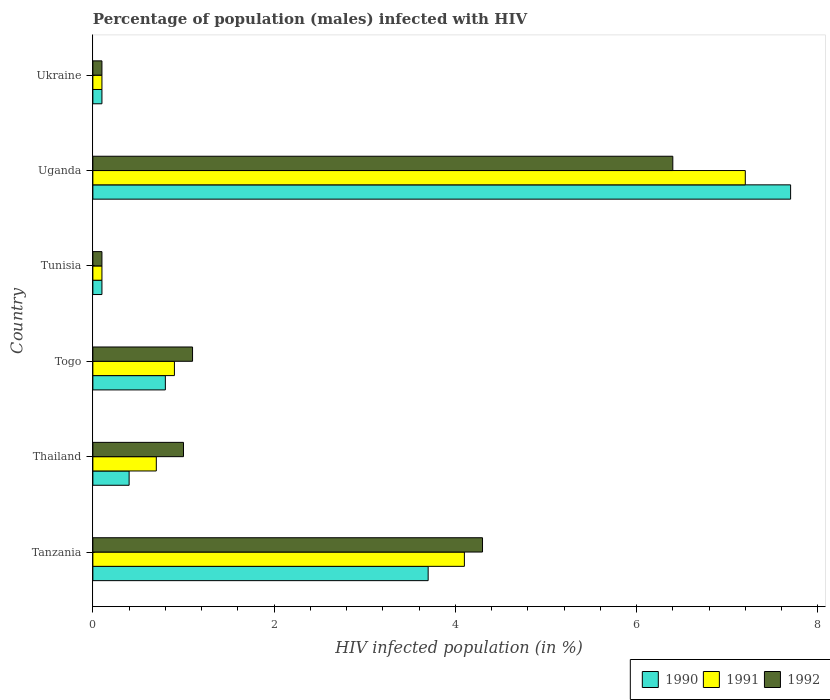Are the number of bars per tick equal to the number of legend labels?
Keep it short and to the point. Yes. Are the number of bars on each tick of the Y-axis equal?
Offer a terse response. Yes. How many bars are there on the 2nd tick from the bottom?
Your answer should be very brief. 3. What is the label of the 6th group of bars from the top?
Ensure brevity in your answer.  Tanzania. What is the percentage of HIV infected male population in 1992 in Tanzania?
Provide a short and direct response. 4.3. Across all countries, what is the maximum percentage of HIV infected male population in 1992?
Keep it short and to the point. 6.4. In which country was the percentage of HIV infected male population in 1991 maximum?
Your answer should be compact. Uganda. In which country was the percentage of HIV infected male population in 1990 minimum?
Offer a very short reply. Tunisia. What is the difference between the percentage of HIV infected male population in 1990 in Uganda and the percentage of HIV infected male population in 1992 in Tanzania?
Ensure brevity in your answer.  3.4. What is the average percentage of HIV infected male population in 1992 per country?
Keep it short and to the point. 2.17. What is the difference between the percentage of HIV infected male population in 1990 and percentage of HIV infected male population in 1991 in Togo?
Provide a succinct answer. -0.1. What is the ratio of the percentage of HIV infected male population in 1990 in Togo to that in Uganda?
Offer a very short reply. 0.1. Is the percentage of HIV infected male population in 1990 in Tanzania less than that in Thailand?
Your response must be concise. No. What is the difference between the highest and the second highest percentage of HIV infected male population in 1991?
Your answer should be very brief. 3.1. What is the difference between the highest and the lowest percentage of HIV infected male population in 1992?
Your answer should be compact. 6.3. What does the 2nd bar from the bottom in Thailand represents?
Offer a terse response. 1991. Is it the case that in every country, the sum of the percentage of HIV infected male population in 1991 and percentage of HIV infected male population in 1990 is greater than the percentage of HIV infected male population in 1992?
Offer a very short reply. Yes. What is the difference between two consecutive major ticks on the X-axis?
Give a very brief answer. 2. Are the values on the major ticks of X-axis written in scientific E-notation?
Offer a very short reply. No. Does the graph contain any zero values?
Offer a very short reply. No. Where does the legend appear in the graph?
Ensure brevity in your answer.  Bottom right. What is the title of the graph?
Give a very brief answer. Percentage of population (males) infected with HIV. What is the label or title of the X-axis?
Offer a terse response. HIV infected population (in %). What is the label or title of the Y-axis?
Ensure brevity in your answer.  Country. What is the HIV infected population (in %) in 1990 in Tanzania?
Offer a very short reply. 3.7. What is the HIV infected population (in %) of 1991 in Tanzania?
Keep it short and to the point. 4.1. What is the HIV infected population (in %) in 1990 in Thailand?
Make the answer very short. 0.4. What is the HIV infected population (in %) of 1992 in Togo?
Make the answer very short. 1.1. What is the HIV infected population (in %) of 1991 in Uganda?
Ensure brevity in your answer.  7.2. What is the HIV infected population (in %) in 1992 in Uganda?
Your response must be concise. 6.4. What is the HIV infected population (in %) of 1990 in Ukraine?
Your answer should be compact. 0.1. Across all countries, what is the maximum HIV infected population (in %) of 1990?
Make the answer very short. 7.7. Across all countries, what is the maximum HIV infected population (in %) in 1992?
Give a very brief answer. 6.4. Across all countries, what is the minimum HIV infected population (in %) of 1990?
Provide a short and direct response. 0.1. Across all countries, what is the minimum HIV infected population (in %) of 1991?
Ensure brevity in your answer.  0.1. What is the total HIV infected population (in %) of 1991 in the graph?
Keep it short and to the point. 13.1. What is the difference between the HIV infected population (in %) in 1992 in Tanzania and that in Thailand?
Make the answer very short. 3.3. What is the difference between the HIV infected population (in %) of 1990 in Tanzania and that in Togo?
Your response must be concise. 2.9. What is the difference between the HIV infected population (in %) of 1990 in Tanzania and that in Tunisia?
Provide a short and direct response. 3.6. What is the difference between the HIV infected population (in %) of 1992 in Tanzania and that in Uganda?
Provide a short and direct response. -2.1. What is the difference between the HIV infected population (in %) of 1990 in Tanzania and that in Ukraine?
Provide a short and direct response. 3.6. What is the difference between the HIV infected population (in %) in 1992 in Tanzania and that in Ukraine?
Give a very brief answer. 4.2. What is the difference between the HIV infected population (in %) in 1992 in Thailand and that in Togo?
Offer a terse response. -0.1. What is the difference between the HIV infected population (in %) in 1990 in Thailand and that in Tunisia?
Your response must be concise. 0.3. What is the difference between the HIV infected population (in %) of 1992 in Thailand and that in Tunisia?
Your response must be concise. 0.9. What is the difference between the HIV infected population (in %) of 1990 in Thailand and that in Uganda?
Keep it short and to the point. -7.3. What is the difference between the HIV infected population (in %) in 1991 in Thailand and that in Uganda?
Your response must be concise. -6.5. What is the difference between the HIV infected population (in %) in 1991 in Thailand and that in Ukraine?
Your answer should be very brief. 0.6. What is the difference between the HIV infected population (in %) in 1990 in Togo and that in Tunisia?
Provide a short and direct response. 0.7. What is the difference between the HIV infected population (in %) of 1991 in Togo and that in Tunisia?
Your answer should be very brief. 0.8. What is the difference between the HIV infected population (in %) of 1990 in Togo and that in Uganda?
Offer a terse response. -6.9. What is the difference between the HIV infected population (in %) in 1991 in Togo and that in Uganda?
Offer a very short reply. -6.3. What is the difference between the HIV infected population (in %) of 1991 in Togo and that in Ukraine?
Your answer should be very brief. 0.8. What is the difference between the HIV infected population (in %) of 1992 in Togo and that in Ukraine?
Make the answer very short. 1. What is the difference between the HIV infected population (in %) in 1992 in Tunisia and that in Uganda?
Your answer should be compact. -6.3. What is the difference between the HIV infected population (in %) of 1992 in Tunisia and that in Ukraine?
Your response must be concise. 0. What is the difference between the HIV infected population (in %) in 1990 in Uganda and that in Ukraine?
Your answer should be very brief. 7.6. What is the difference between the HIV infected population (in %) in 1990 in Tanzania and the HIV infected population (in %) in 1992 in Thailand?
Make the answer very short. 2.7. What is the difference between the HIV infected population (in %) in 1991 in Tanzania and the HIV infected population (in %) in 1992 in Thailand?
Your answer should be very brief. 3.1. What is the difference between the HIV infected population (in %) of 1990 in Tanzania and the HIV infected population (in %) of 1992 in Togo?
Offer a terse response. 2.6. What is the difference between the HIV infected population (in %) of 1991 in Tanzania and the HIV infected population (in %) of 1992 in Togo?
Your answer should be very brief. 3. What is the difference between the HIV infected population (in %) in 1991 in Tanzania and the HIV infected population (in %) in 1992 in Tunisia?
Your answer should be very brief. 4. What is the difference between the HIV infected population (in %) in 1990 in Tanzania and the HIV infected population (in %) in 1991 in Uganda?
Your answer should be very brief. -3.5. What is the difference between the HIV infected population (in %) of 1991 in Tanzania and the HIV infected population (in %) of 1992 in Uganda?
Offer a very short reply. -2.3. What is the difference between the HIV infected population (in %) of 1990 in Tanzania and the HIV infected population (in %) of 1992 in Ukraine?
Your answer should be compact. 3.6. What is the difference between the HIV infected population (in %) in 1991 in Tanzania and the HIV infected population (in %) in 1992 in Ukraine?
Your response must be concise. 4. What is the difference between the HIV infected population (in %) of 1990 in Thailand and the HIV infected population (in %) of 1991 in Togo?
Your answer should be very brief. -0.5. What is the difference between the HIV infected population (in %) in 1990 in Thailand and the HIV infected population (in %) in 1992 in Togo?
Your answer should be very brief. -0.7. What is the difference between the HIV infected population (in %) in 1990 in Thailand and the HIV infected population (in %) in 1991 in Tunisia?
Offer a very short reply. 0.3. What is the difference between the HIV infected population (in %) of 1990 in Thailand and the HIV infected population (in %) of 1992 in Tunisia?
Your answer should be compact. 0.3. What is the difference between the HIV infected population (in %) of 1991 in Thailand and the HIV infected population (in %) of 1992 in Tunisia?
Your answer should be compact. 0.6. What is the difference between the HIV infected population (in %) in 1990 in Thailand and the HIV infected population (in %) in 1992 in Uganda?
Offer a very short reply. -6. What is the difference between the HIV infected population (in %) in 1991 in Thailand and the HIV infected population (in %) in 1992 in Uganda?
Give a very brief answer. -5.7. What is the difference between the HIV infected population (in %) of 1990 in Togo and the HIV infected population (in %) of 1991 in Tunisia?
Ensure brevity in your answer.  0.7. What is the difference between the HIV infected population (in %) in 1991 in Togo and the HIV infected population (in %) in 1992 in Tunisia?
Offer a very short reply. 0.8. What is the difference between the HIV infected population (in %) of 1990 in Togo and the HIV infected population (in %) of 1991 in Uganda?
Offer a terse response. -6.4. What is the difference between the HIV infected population (in %) in 1990 in Togo and the HIV infected population (in %) in 1992 in Uganda?
Keep it short and to the point. -5.6. What is the difference between the HIV infected population (in %) in 1990 in Togo and the HIV infected population (in %) in 1991 in Ukraine?
Offer a very short reply. 0.7. What is the difference between the HIV infected population (in %) of 1990 in Togo and the HIV infected population (in %) of 1992 in Ukraine?
Offer a very short reply. 0.7. What is the difference between the HIV infected population (in %) in 1990 in Tunisia and the HIV infected population (in %) in 1992 in Uganda?
Provide a short and direct response. -6.3. What is the difference between the HIV infected population (in %) in 1990 in Tunisia and the HIV infected population (in %) in 1992 in Ukraine?
Provide a succinct answer. 0. What is the difference between the HIV infected population (in %) of 1991 in Tunisia and the HIV infected population (in %) of 1992 in Ukraine?
Provide a short and direct response. 0. What is the difference between the HIV infected population (in %) of 1990 in Uganda and the HIV infected population (in %) of 1992 in Ukraine?
Your answer should be compact. 7.6. What is the average HIV infected population (in %) of 1990 per country?
Offer a terse response. 2.13. What is the average HIV infected population (in %) of 1991 per country?
Your response must be concise. 2.18. What is the average HIV infected population (in %) in 1992 per country?
Keep it short and to the point. 2.17. What is the difference between the HIV infected population (in %) of 1990 and HIV infected population (in %) of 1991 in Tanzania?
Your response must be concise. -0.4. What is the difference between the HIV infected population (in %) in 1990 and HIV infected population (in %) in 1992 in Thailand?
Ensure brevity in your answer.  -0.6. What is the difference between the HIV infected population (in %) in 1991 and HIV infected population (in %) in 1992 in Thailand?
Make the answer very short. -0.3. What is the difference between the HIV infected population (in %) in 1990 and HIV infected population (in %) in 1992 in Togo?
Your answer should be compact. -0.3. What is the difference between the HIV infected population (in %) of 1991 and HIV infected population (in %) of 1992 in Togo?
Give a very brief answer. -0.2. What is the difference between the HIV infected population (in %) in 1990 and HIV infected population (in %) in 1991 in Tunisia?
Give a very brief answer. 0. What is the difference between the HIV infected population (in %) in 1990 and HIV infected population (in %) in 1992 in Tunisia?
Your response must be concise. 0. What is the difference between the HIV infected population (in %) of 1990 and HIV infected population (in %) of 1991 in Uganda?
Your answer should be very brief. 0.5. What is the difference between the HIV infected population (in %) in 1990 and HIV infected population (in %) in 1991 in Ukraine?
Ensure brevity in your answer.  0. What is the difference between the HIV infected population (in %) in 1990 and HIV infected population (in %) in 1992 in Ukraine?
Make the answer very short. 0. What is the difference between the HIV infected population (in %) in 1991 and HIV infected population (in %) in 1992 in Ukraine?
Your response must be concise. 0. What is the ratio of the HIV infected population (in %) of 1990 in Tanzania to that in Thailand?
Give a very brief answer. 9.25. What is the ratio of the HIV infected population (in %) in 1991 in Tanzania to that in Thailand?
Give a very brief answer. 5.86. What is the ratio of the HIV infected population (in %) of 1990 in Tanzania to that in Togo?
Keep it short and to the point. 4.62. What is the ratio of the HIV infected population (in %) of 1991 in Tanzania to that in Togo?
Offer a terse response. 4.56. What is the ratio of the HIV infected population (in %) of 1992 in Tanzania to that in Togo?
Offer a very short reply. 3.91. What is the ratio of the HIV infected population (in %) of 1991 in Tanzania to that in Tunisia?
Provide a short and direct response. 41. What is the ratio of the HIV infected population (in %) in 1990 in Tanzania to that in Uganda?
Keep it short and to the point. 0.48. What is the ratio of the HIV infected population (in %) in 1991 in Tanzania to that in Uganda?
Provide a short and direct response. 0.57. What is the ratio of the HIV infected population (in %) in 1992 in Tanzania to that in Uganda?
Make the answer very short. 0.67. What is the ratio of the HIV infected population (in %) of 1990 in Tanzania to that in Ukraine?
Keep it short and to the point. 37. What is the ratio of the HIV infected population (in %) in 1991 in Tanzania to that in Ukraine?
Provide a succinct answer. 41. What is the ratio of the HIV infected population (in %) of 1990 in Thailand to that in Togo?
Make the answer very short. 0.5. What is the ratio of the HIV infected population (in %) of 1991 in Thailand to that in Togo?
Your response must be concise. 0.78. What is the ratio of the HIV infected population (in %) in 1992 in Thailand to that in Togo?
Your response must be concise. 0.91. What is the ratio of the HIV infected population (in %) in 1991 in Thailand to that in Tunisia?
Offer a very short reply. 7. What is the ratio of the HIV infected population (in %) in 1992 in Thailand to that in Tunisia?
Offer a terse response. 10. What is the ratio of the HIV infected population (in %) of 1990 in Thailand to that in Uganda?
Offer a very short reply. 0.05. What is the ratio of the HIV infected population (in %) of 1991 in Thailand to that in Uganda?
Give a very brief answer. 0.1. What is the ratio of the HIV infected population (in %) of 1992 in Thailand to that in Uganda?
Your answer should be compact. 0.16. What is the ratio of the HIV infected population (in %) in 1992 in Thailand to that in Ukraine?
Provide a short and direct response. 10. What is the ratio of the HIV infected population (in %) in 1990 in Togo to that in Uganda?
Your answer should be compact. 0.1. What is the ratio of the HIV infected population (in %) in 1991 in Togo to that in Uganda?
Provide a succinct answer. 0.12. What is the ratio of the HIV infected population (in %) in 1992 in Togo to that in Uganda?
Make the answer very short. 0.17. What is the ratio of the HIV infected population (in %) in 1991 in Togo to that in Ukraine?
Your answer should be compact. 9. What is the ratio of the HIV infected population (in %) of 1992 in Togo to that in Ukraine?
Provide a succinct answer. 11. What is the ratio of the HIV infected population (in %) of 1990 in Tunisia to that in Uganda?
Provide a short and direct response. 0.01. What is the ratio of the HIV infected population (in %) of 1991 in Tunisia to that in Uganda?
Ensure brevity in your answer.  0.01. What is the ratio of the HIV infected population (in %) in 1992 in Tunisia to that in Uganda?
Your answer should be very brief. 0.02. What is the ratio of the HIV infected population (in %) in 1990 in Tunisia to that in Ukraine?
Offer a very short reply. 1. What is the ratio of the HIV infected population (in %) in 1992 in Uganda to that in Ukraine?
Make the answer very short. 64. What is the difference between the highest and the second highest HIV infected population (in %) of 1990?
Give a very brief answer. 4. What is the difference between the highest and the lowest HIV infected population (in %) in 1990?
Your answer should be compact. 7.6. What is the difference between the highest and the lowest HIV infected population (in %) in 1992?
Your response must be concise. 6.3. 